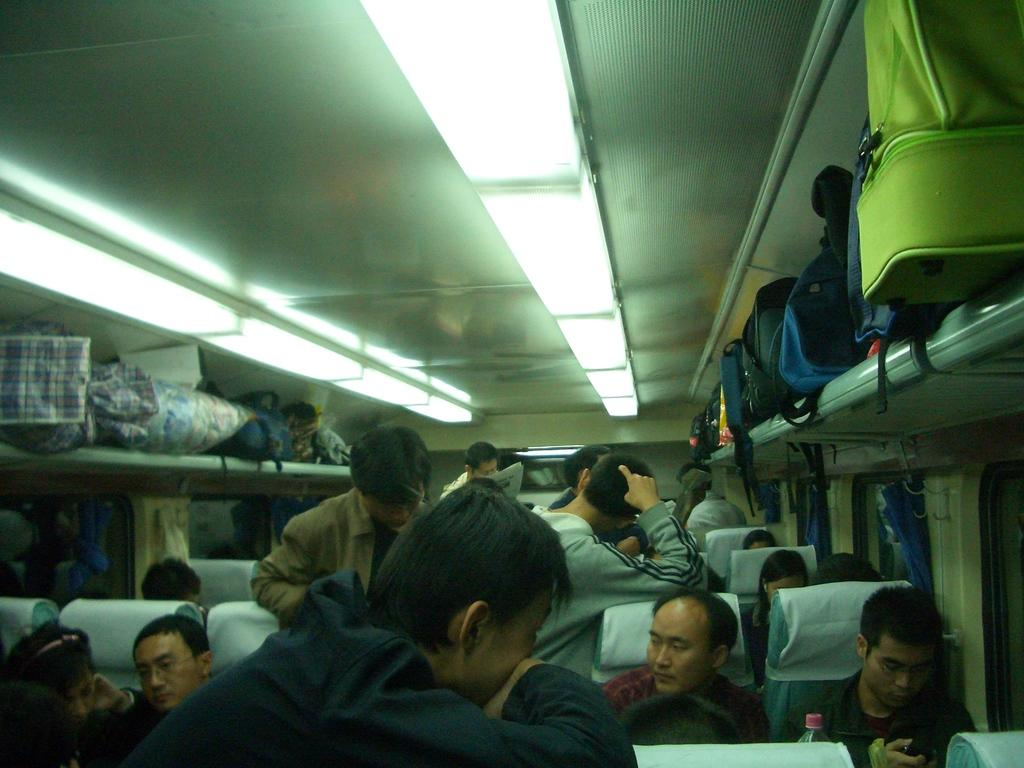What are the people in the image doing? Some people are sitting, and some are standing in the image. Can you describe any objects related to travel in the image? There is luggage kept on a shelf in the image. What type of lighting is present in the image? There are lights on the ceiling in the image. What type of copper material is used to make the sweater in the image? There is no sweater or copper material present in the image. Can you describe the nest that the birds are building in the image? There are no birds or nests present in the image. 